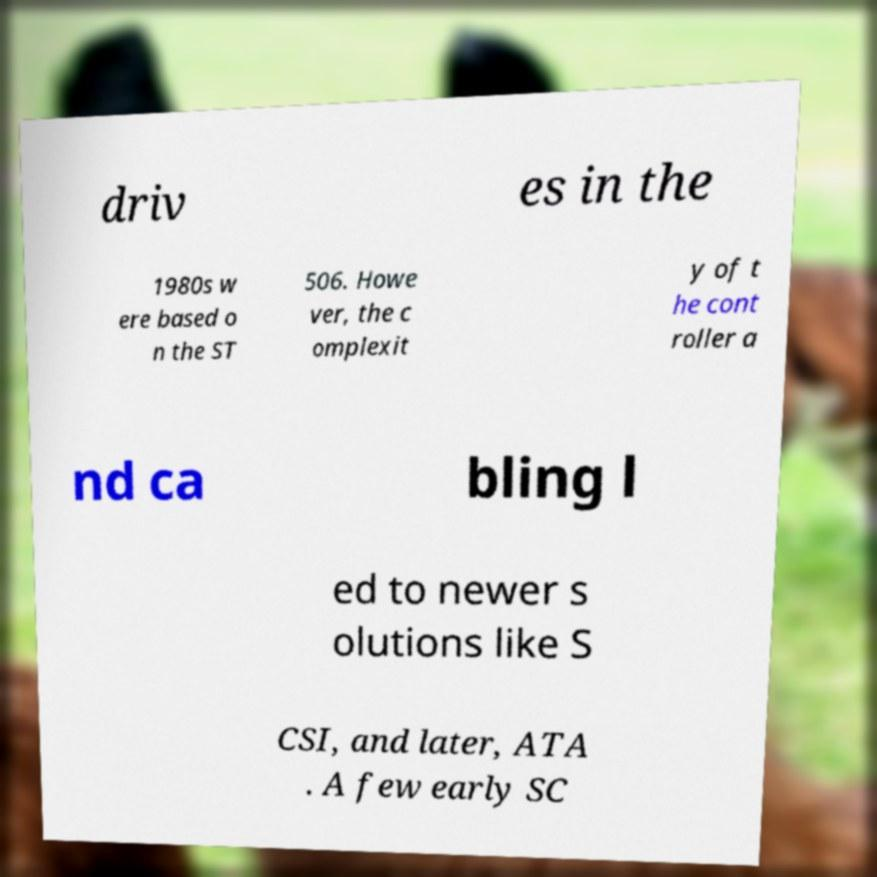Could you assist in decoding the text presented in this image and type it out clearly? driv es in the 1980s w ere based o n the ST 506. Howe ver, the c omplexit y of t he cont roller a nd ca bling l ed to newer s olutions like S CSI, and later, ATA . A few early SC 